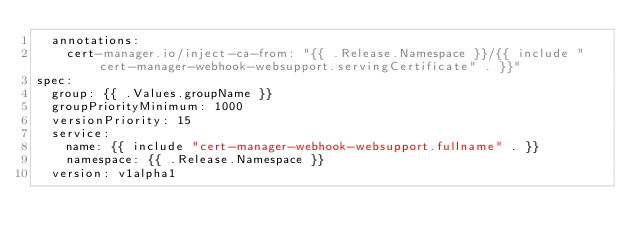Convert code to text. <code><loc_0><loc_0><loc_500><loc_500><_YAML_>  annotations:
    cert-manager.io/inject-ca-from: "{{ .Release.Namespace }}/{{ include "cert-manager-webhook-websupport.servingCertificate" . }}"
spec:
  group: {{ .Values.groupName }}
  groupPriorityMinimum: 1000
  versionPriority: 15
  service:
    name: {{ include "cert-manager-webhook-websupport.fullname" . }}
    namespace: {{ .Release.Namespace }}
  version: v1alpha1
</code> 